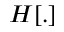Convert formula to latex. <formula><loc_0><loc_0><loc_500><loc_500>H [ . ]</formula> 